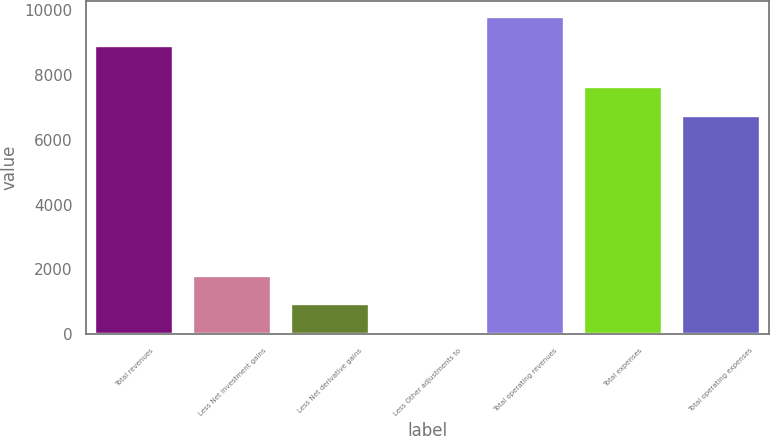<chart> <loc_0><loc_0><loc_500><loc_500><bar_chart><fcel>Total revenues<fcel>Less Net investment gains<fcel>Less Net derivative gains<fcel>Less Other adjustments to<fcel>Total operating revenues<fcel>Total expenses<fcel>Total operating expenses<nl><fcel>8901<fcel>1806.4<fcel>911.7<fcel>17<fcel>9795.7<fcel>7629.7<fcel>6735<nl></chart> 